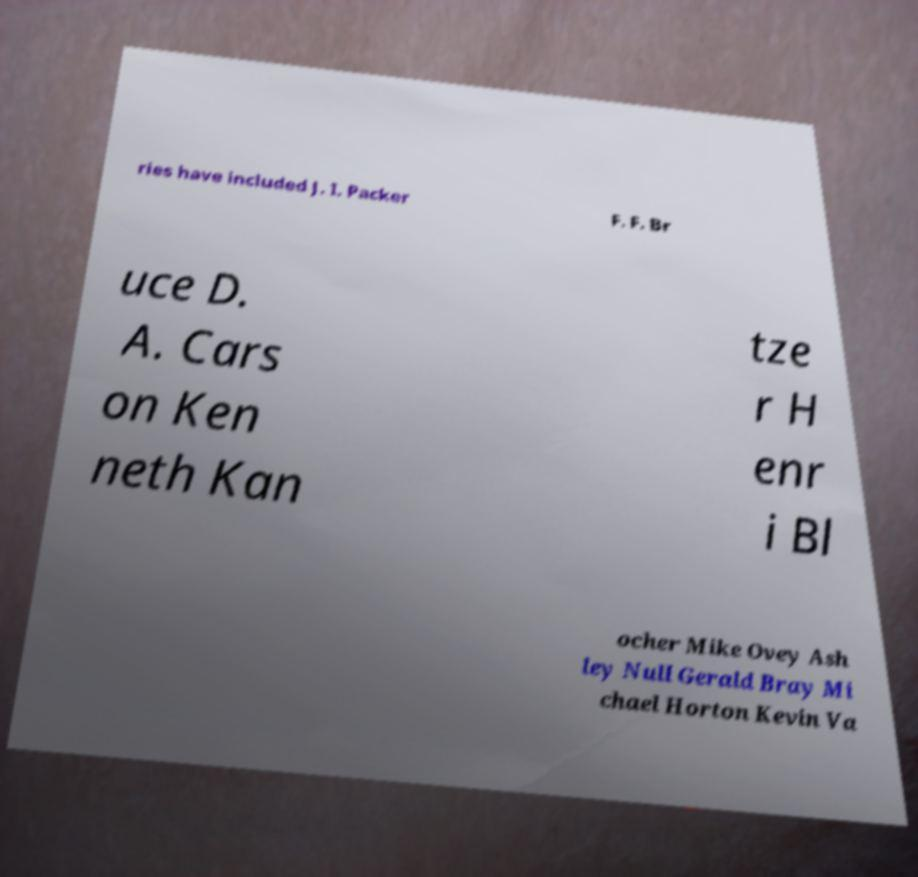Could you assist in decoding the text presented in this image and type it out clearly? ries have included J. I. Packer F. F. Br uce D. A. Cars on Ken neth Kan tze r H enr i Bl ocher Mike Ovey Ash ley Null Gerald Bray Mi chael Horton Kevin Va 